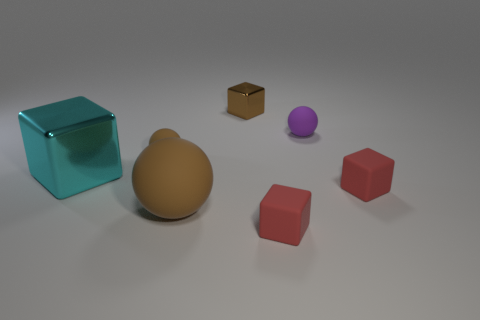The matte thing that is both left of the tiny metallic cube and in front of the tiny brown sphere is what color?
Provide a short and direct response. Brown. Is there a small cylinder that has the same material as the purple object?
Provide a succinct answer. No. What size is the brown shiny cube?
Offer a very short reply. Small. There is a matte cube that is on the right side of the small thing that is in front of the large matte thing; how big is it?
Keep it short and to the point. Small. What material is the other large thing that is the same shape as the purple thing?
Your answer should be compact. Rubber. How many yellow rubber cylinders are there?
Offer a very short reply. 0. There is a matte thing that is behind the small matte ball left of the small red matte thing left of the purple sphere; what color is it?
Your response must be concise. Purple. Are there fewer big gray shiny blocks than big brown spheres?
Offer a very short reply. Yes. What color is the small metal thing that is the same shape as the large cyan shiny thing?
Give a very brief answer. Brown. There is a large sphere that is made of the same material as the small brown ball; what color is it?
Ensure brevity in your answer.  Brown. 